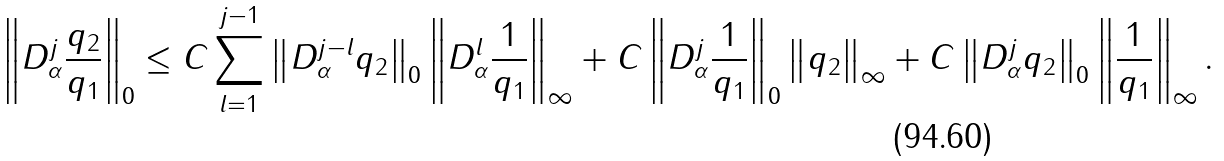Convert formula to latex. <formula><loc_0><loc_0><loc_500><loc_500>\left \| D _ { \alpha } ^ { j } \frac { q _ { 2 } } { q _ { 1 } } \right \| _ { 0 } \leq C \sum _ { l = 1 } ^ { j - 1 } \left \| D _ { \alpha } ^ { j - l } q _ { 2 } \right \| _ { 0 } \left \| D ^ { l } _ { \alpha } \frac { 1 } { q _ { 1 } } \right \| _ { \infty } + C \left \| D _ { \alpha } ^ { j } \frac { 1 } { q _ { 1 } } \right \| _ { 0 } \left \| q _ { 2 } \right \| _ { \infty } + C \left \| D _ { \alpha } ^ { j } q _ { 2 } \right \| _ { 0 } \left \| \frac { 1 } { q _ { 1 } } \right \| _ { \infty } .</formula> 